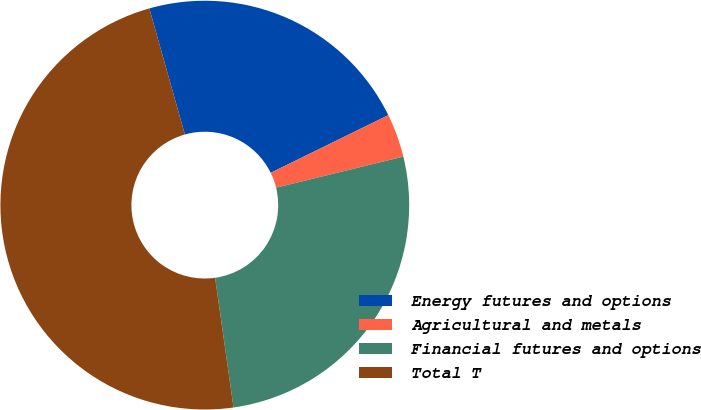Convert chart to OTSL. <chart><loc_0><loc_0><loc_500><loc_500><pie_chart><fcel>Energy futures and options<fcel>Agricultural and metals<fcel>Financial futures and options<fcel>Total T<nl><fcel>22.12%<fcel>3.44%<fcel>26.57%<fcel>47.87%<nl></chart> 